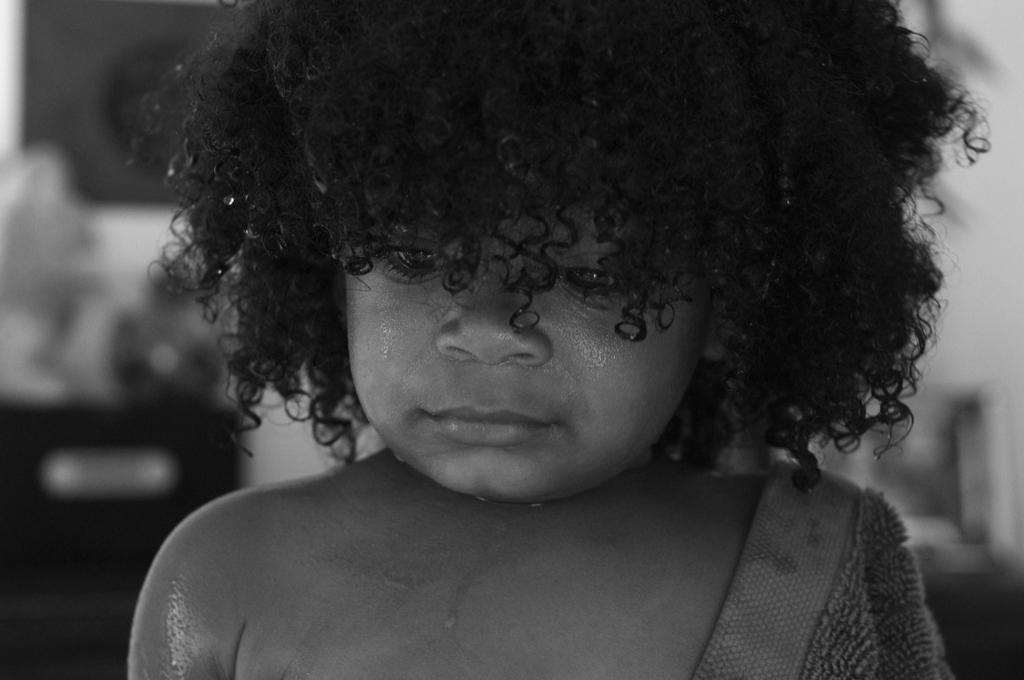What is the color scheme of the image? The image is black and white. What is the main subject of the image? There is a kid in the image. Can you describe the background of the image? The background of the image is blurred. What type of rabbit can be seen in the background of the image? There is no rabbit present in the image, and the background is blurred, so it is not possible to see any animals. 